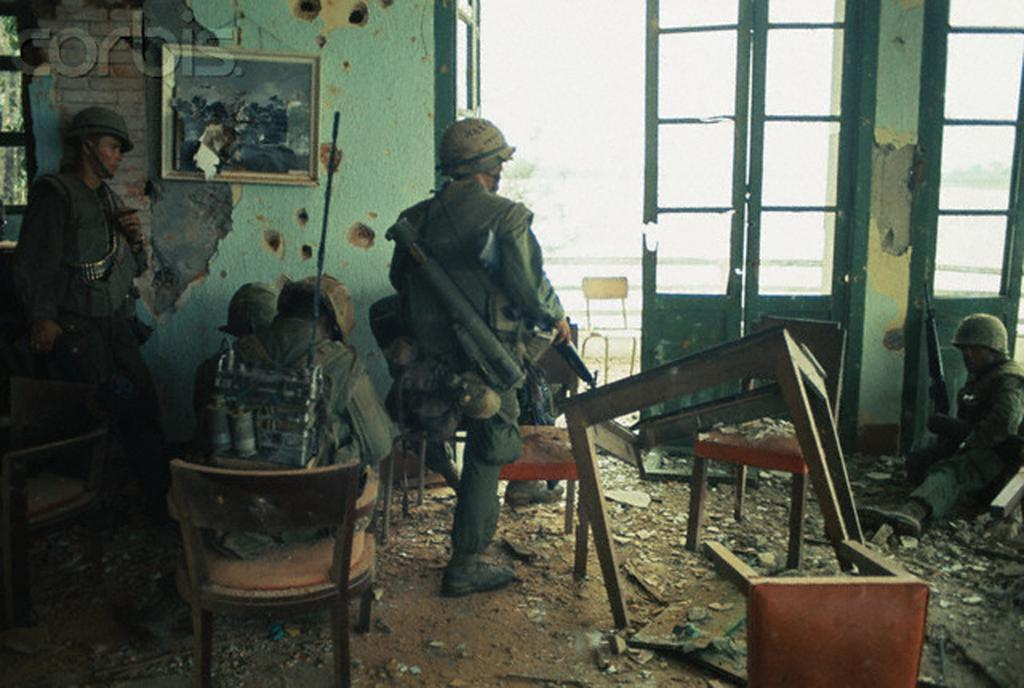How many men are in the image? There are three men in the image. What are the positions of the men in the image? Two of the men are standing, and one man is sitting on a chair. What type of furniture is present in the image? There are tables and chairs in the image. What architectural feature can be seen in the image? There is a door in the image. What type of decoration is present on the wall? There is a frame on the wall in the image. What type of material is visible in the image? There is some material visible in the image. How many feet are visible in the image? There is no specific mention of feet in the image, so it is not possible to determine how many are visible. 